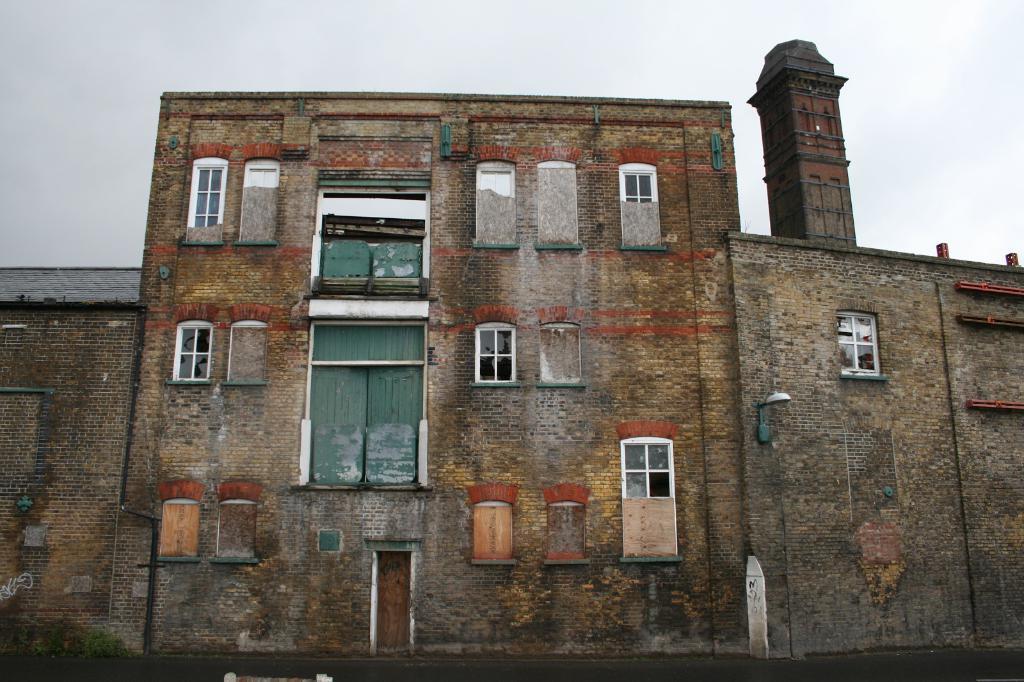Could you give a brief overview of what you see in this image? This picture is taken from outside of the building. In this image, we can see a building, door, glass window. On the right side building, we can see a pillar. At the top, we can see a sky which is cloudy. 